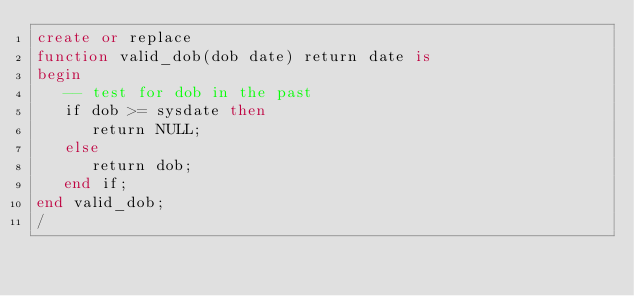<code> <loc_0><loc_0><loc_500><loc_500><_SQL_>create or replace
function valid_dob(dob date) return date is
begin
   -- test for dob in the past
   if dob >= sysdate then
      return NULL;
   else
      return dob;
   end if;
end valid_dob;
/
</code> 